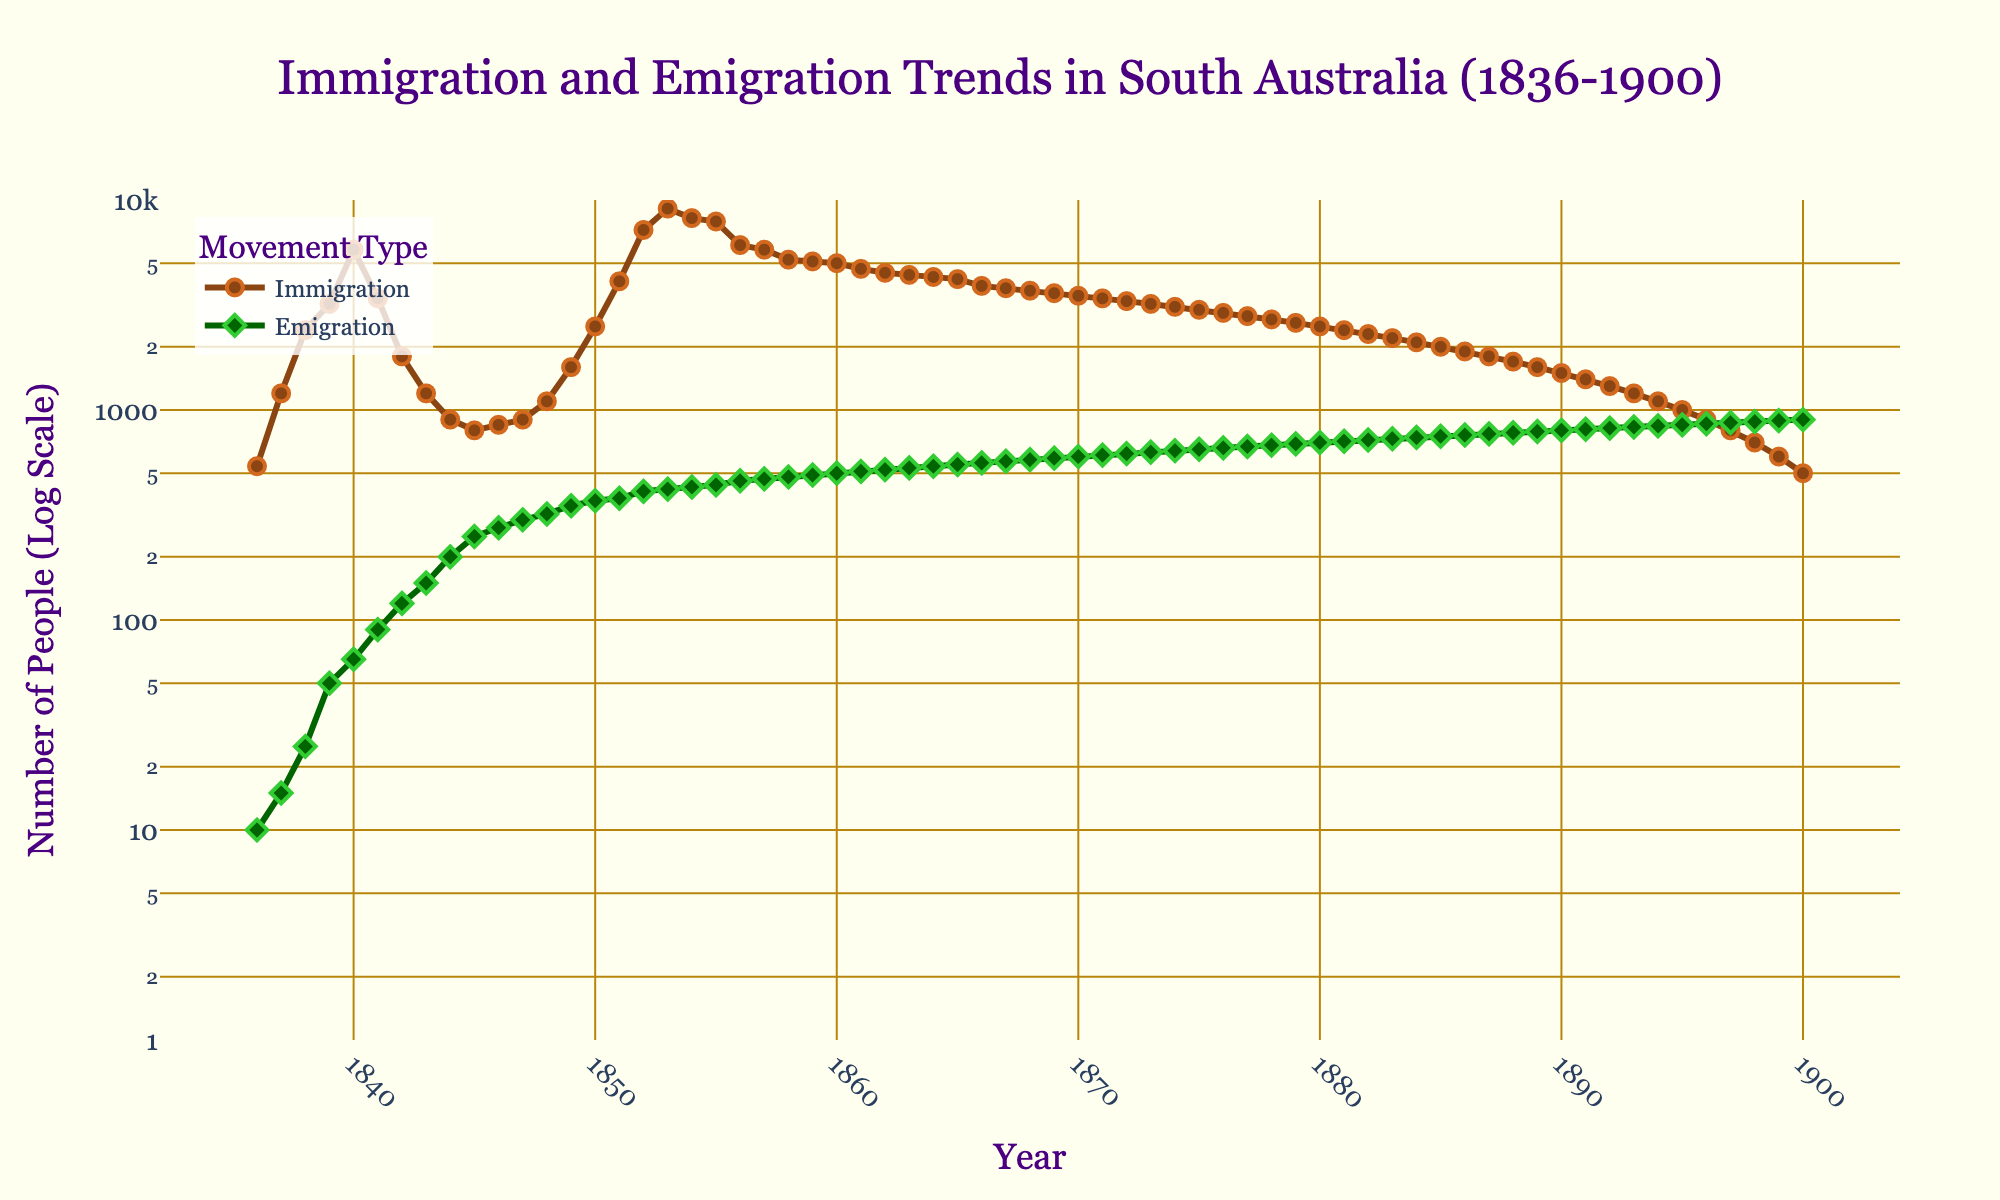What is the title of the figure? The title of the figure is generally positioned at the top and is written in a larger and bolder font compared to other text on the plot. In this case, it should be clear from the plot.
Answer: Immigration and Emigration Trends in South Australia (1836-1900) What are the y-axis units in the plot? The y-axis units can be identified by reading the y-axis title in the plot, which should provide the units used for the data values.
Answer: Number of People (Log Scale) What is the value of immigration in 1853? Locate the year 1853 on the x-axis, then follow the corresponding value on the y-axis for the Immigration trend (brown line and circle markers).
Answer: 9100 In what year did emigration surpass 500 for the first time? To find this, follow the emigration trend (green line and diamond markers) from the beginning to identify the first year where the value goes above 500 on the log scale y-axis.
Answer: 1860 What was the immigration trend from 1836 to 1840? Examine the line representing immigration from 1836 to 1840, noting that it started around 540 in 1836 and increased to about 5800 in 1840.
Answer: Increasing How many years did immigration stay higher than 5000? Identify the years where the immigration value on the y-axis exceeded 5000 and count those years, considering the log scale.
Answer: 13 Compare the immigration and emigration values in 1875. Which was higher and by how much? Check the values for both immigration and emigration in the year 1875 and calculate the difference between them: Immigration (3000) vs. Emigration (650).
Answer: Immigration was higher by 2350 What is the overall trend of emigration from 1860 to 1900? Observe the emigration trend line from the year 1860 to 1900. Note that it generally shows an increasing trend, rising from around 500 to 900.
Answer: Increasing How does the range of the y-axis affect the visualization of the trends? The log scale compresses larger values and expands smaller values, making it easier to observe trends over a wide range of magnitudes compared to a linear scale.
Answer: It enhances the visualization over wide magnitudes In which decade did immigration show the most significant decline? Analyze the immigration trend line and identify the decade with the most steep and noticeable drop. Focus on the period between 1860s to 1900.
Answer: 1840s 